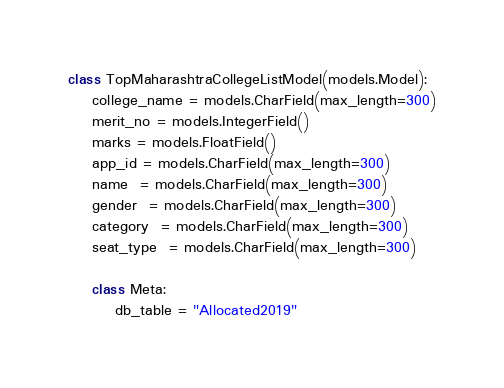Convert code to text. <code><loc_0><loc_0><loc_500><loc_500><_Python_>

class TopMaharashtraCollegeListModel(models.Model):
    college_name = models.CharField(max_length=300)
    merit_no = models.IntegerField()
    marks = models.FloatField()
    app_id = models.CharField(max_length=300)
    name  = models.CharField(max_length=300)
    gender  = models.CharField(max_length=300)
    category  = models.CharField(max_length=300)
    seat_type  = models.CharField(max_length=300)
   
    class Meta:
        db_table = "Allocated2019" </code> 